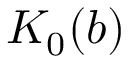Convert formula to latex. <formula><loc_0><loc_0><loc_500><loc_500>K _ { 0 } ( b )</formula> 